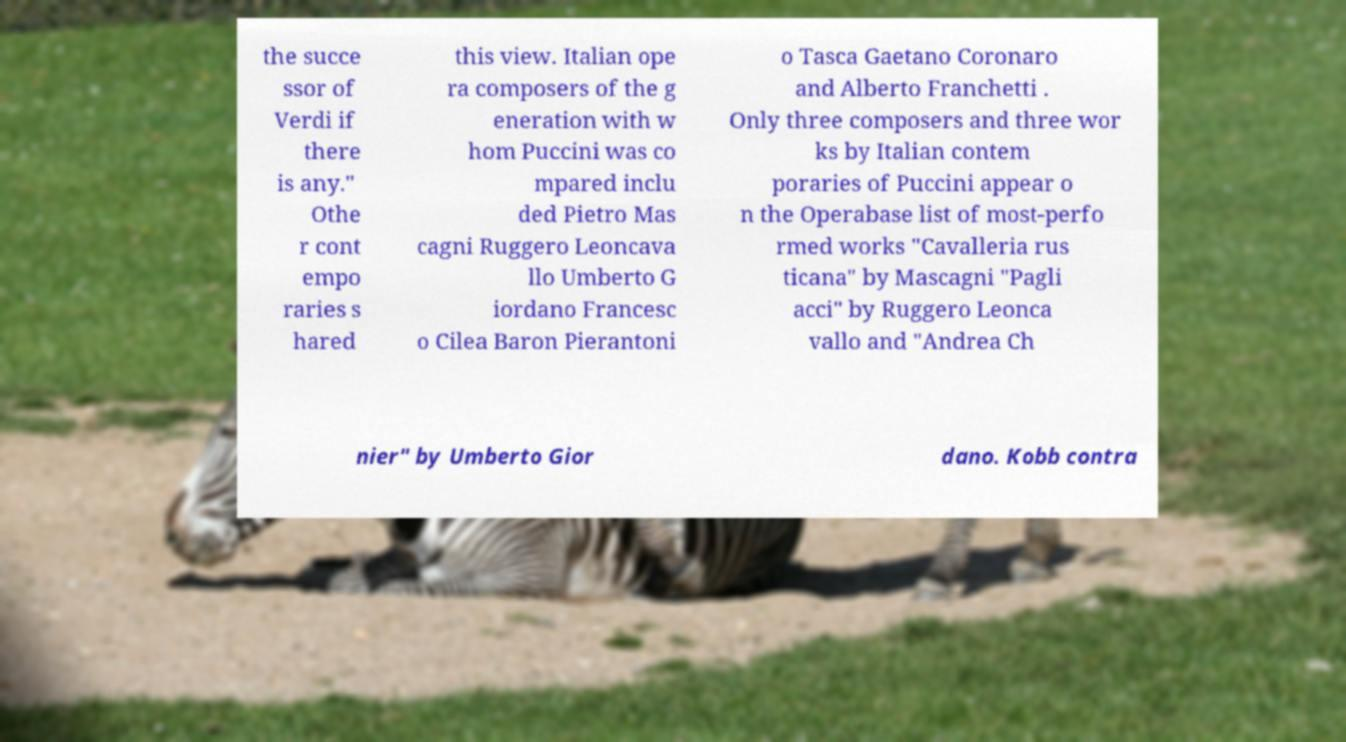Please read and relay the text visible in this image. What does it say? the succe ssor of Verdi if there is any." Othe r cont empo raries s hared this view. Italian ope ra composers of the g eneration with w hom Puccini was co mpared inclu ded Pietro Mas cagni Ruggero Leoncava llo Umberto G iordano Francesc o Cilea Baron Pierantoni o Tasca Gaetano Coronaro and Alberto Franchetti . Only three composers and three wor ks by Italian contem poraries of Puccini appear o n the Operabase list of most-perfo rmed works "Cavalleria rus ticana" by Mascagni "Pagli acci" by Ruggero Leonca vallo and "Andrea Ch nier" by Umberto Gior dano. Kobb contra 